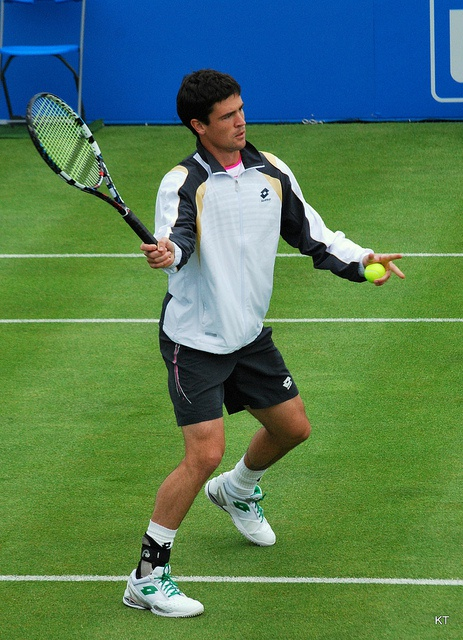Describe the objects in this image and their specific colors. I can see people in blue, black, lightgray, lightblue, and brown tones, tennis racket in blue, black, green, and lightgreen tones, chair in blue, gray, and darkblue tones, and sports ball in blue, yellow, lime, and khaki tones in this image. 